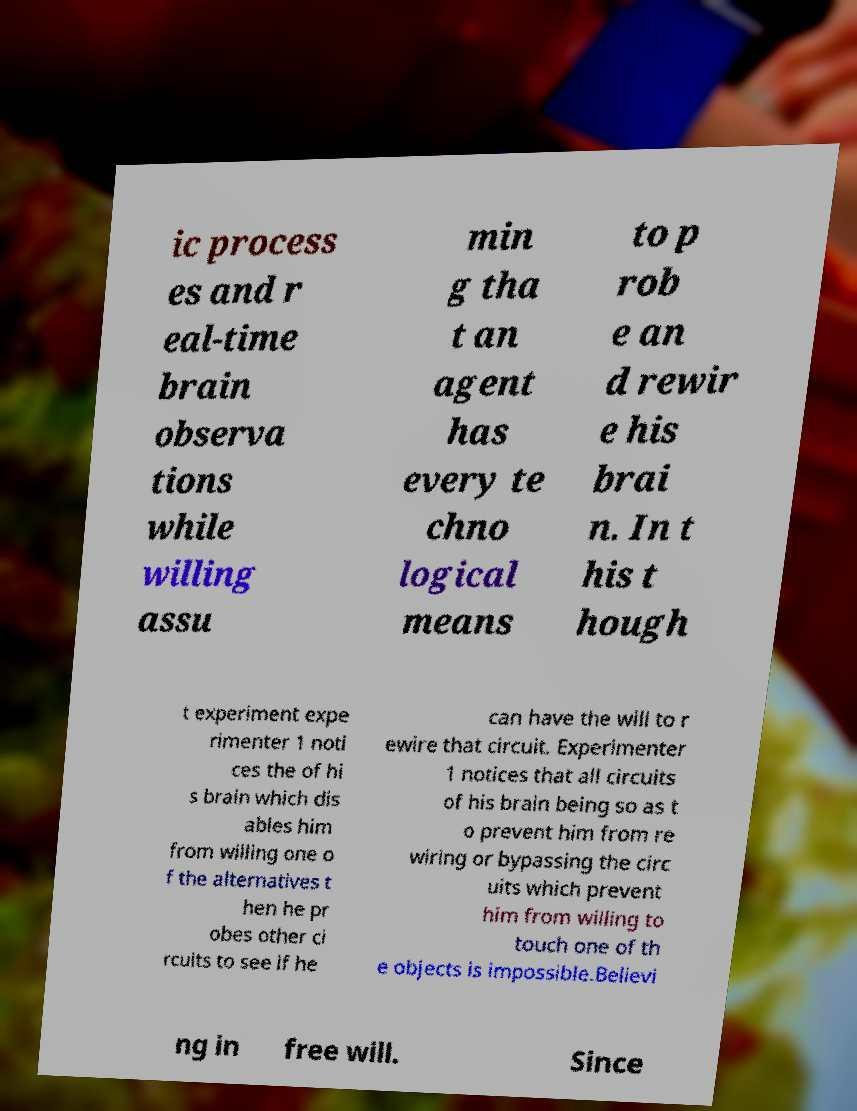Please identify and transcribe the text found in this image. ic process es and r eal-time brain observa tions while willing assu min g tha t an agent has every te chno logical means to p rob e an d rewir e his brai n. In t his t hough t experiment expe rimenter 1 noti ces the of hi s brain which dis ables him from willing one o f the alternatives t hen he pr obes other ci rcuits to see if he can have the will to r ewire that circuit. Experimenter 1 notices that all circuits of his brain being so as t o prevent him from re wiring or bypassing the circ uits which prevent him from willing to touch one of th e objects is impossible.Believi ng in free will. Since 